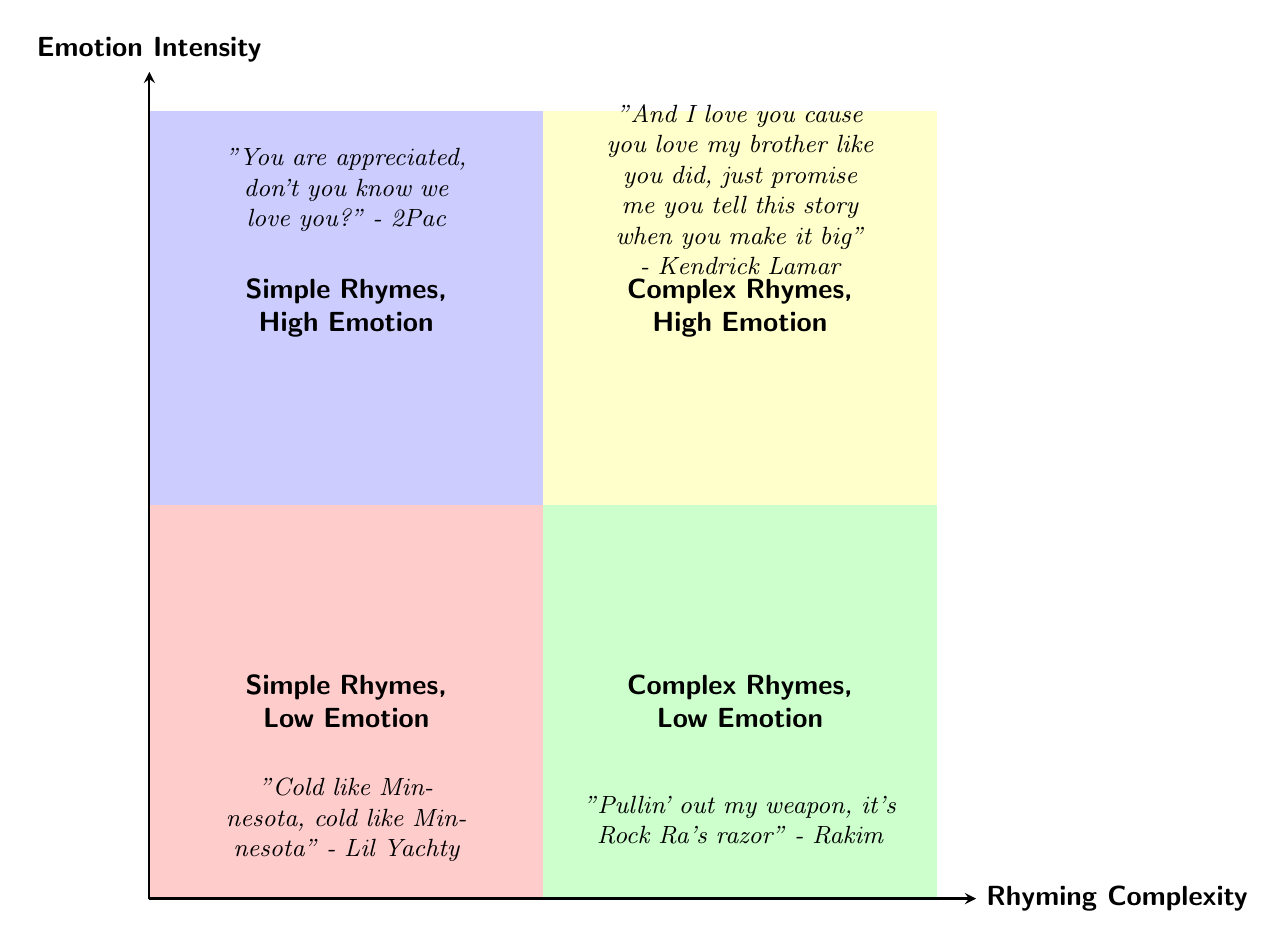What are the four quadrants categorized by in the diagram? The quadrants are categorized by "Rhyming Complexity" on the x-axis and "Emotion Intensity" on the y-axis. Each quadrant represents a different combination of these two attributes.
Answer: Rhyming Complexity and Emotion Intensity Which artist is associated with the "Complex Rhymes, High Emotion" quadrant? In that quadrant, the example provided is from Kendrick Lamar's song. He is labeled there as the artist that combines complex rhymes with high emotional impact.
Answer: Kendrick Lamar How many examples of songs are provided in the "Simple Rhymes, Low Emotion" quadrant? The diagram shows one example song listed in this quadrant, which indicates that it represents that specific category of lyrics.
Answer: 1 What emotion intensity level is associated with "Pullin' out my weapon, it's Rock Ra's razor"? The lyrics come from the "Complex Rhymes, Low Emotion" quadrant, indicating that they have intricate rhymes but lack deep emotional content.
Answer: Low Emotion What is the main lyrical theme expressed in the "Simple Rhymes, High Emotion" quadrant? The lyrics here convey appreciation and love, showing a strong emotional connection despite using simple rhymes. This indicates a focus on emotional expression over complexity.
Answer: Appreciation and love Which quadrant contains the lyrics "You are appreciated, don't you know we love you?" This lyric snippet belongs in the "Simple Rhymes, High Emotion" quadrant, which highlights its straightforward rhyme structure and deep emotional resonance.
Answer: Simple Rhymes, High Emotion Identify the rhyme complexity level of the song "Dear Mama." "Dear Mama" is categorized under the "Simple Rhymes, High Emotion" quadrant, meaning it uses simple rhymes while conveying strong emotion.
Answer: Simple Rhymes Compare the emotional intensity of the lyrics "And I love you cause you love my brother like you did" to "Cold like Minnesota." The first lyric from Kendrick Lamar is in the "Complex Rhymes, High Emotion" quadrant, which indicates higher emotional intensity compared to the second lyric, which is in the "Simple Rhymes, Low Emotion" quadrant, reflecting lower emotional depth.
Answer: Higher emotional intensity 